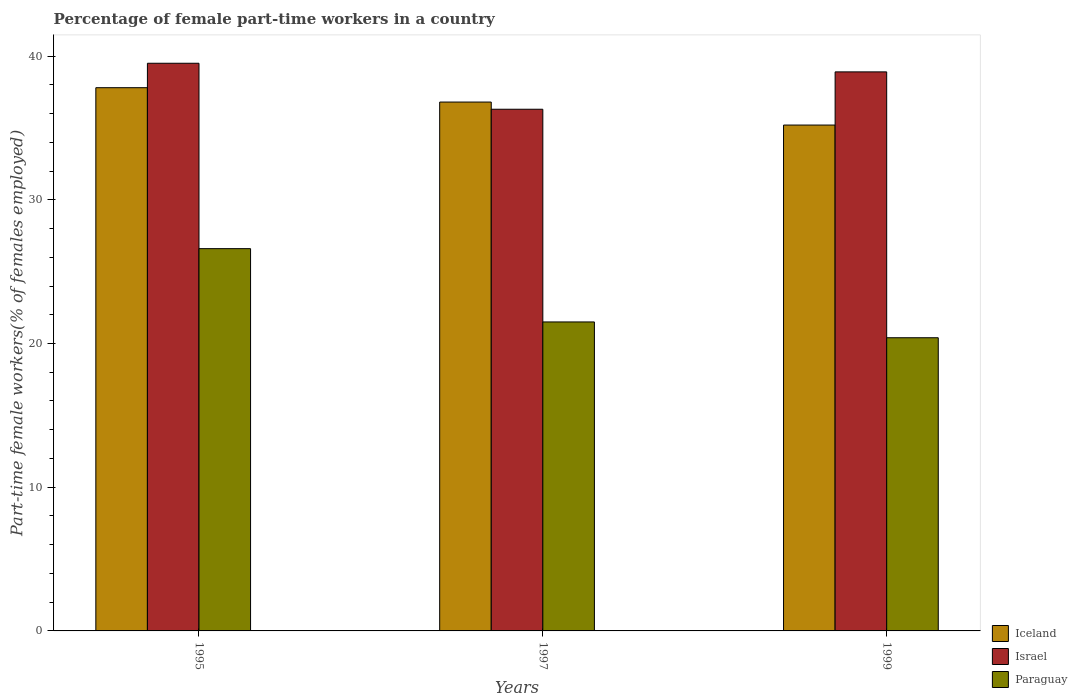How many groups of bars are there?
Offer a terse response. 3. How many bars are there on the 2nd tick from the left?
Make the answer very short. 3. What is the percentage of female part-time workers in Iceland in 1995?
Give a very brief answer. 37.8. Across all years, what is the maximum percentage of female part-time workers in Iceland?
Your response must be concise. 37.8. Across all years, what is the minimum percentage of female part-time workers in Iceland?
Ensure brevity in your answer.  35.2. In which year was the percentage of female part-time workers in Paraguay maximum?
Your answer should be very brief. 1995. What is the total percentage of female part-time workers in Israel in the graph?
Your response must be concise. 114.7. What is the difference between the percentage of female part-time workers in Israel in 1995 and that in 1997?
Provide a succinct answer. 3.2. What is the difference between the percentage of female part-time workers in Israel in 1997 and the percentage of female part-time workers in Iceland in 1995?
Provide a succinct answer. -1.5. What is the average percentage of female part-time workers in Iceland per year?
Your answer should be very brief. 36.6. In the year 1997, what is the difference between the percentage of female part-time workers in Israel and percentage of female part-time workers in Paraguay?
Provide a short and direct response. 14.8. What is the ratio of the percentage of female part-time workers in Israel in 1995 to that in 1999?
Offer a very short reply. 1.02. Is the percentage of female part-time workers in Paraguay in 1995 less than that in 1999?
Your response must be concise. No. Is the difference between the percentage of female part-time workers in Israel in 1995 and 1997 greater than the difference between the percentage of female part-time workers in Paraguay in 1995 and 1997?
Give a very brief answer. No. What is the difference between the highest and the second highest percentage of female part-time workers in Israel?
Ensure brevity in your answer.  0.6. What is the difference between the highest and the lowest percentage of female part-time workers in Israel?
Offer a terse response. 3.2. In how many years, is the percentage of female part-time workers in Iceland greater than the average percentage of female part-time workers in Iceland taken over all years?
Your response must be concise. 2. What does the 2nd bar from the left in 1997 represents?
Offer a terse response. Israel. What does the 1st bar from the right in 1999 represents?
Your response must be concise. Paraguay. How many bars are there?
Ensure brevity in your answer.  9. Are all the bars in the graph horizontal?
Make the answer very short. No. How many years are there in the graph?
Provide a succinct answer. 3. Where does the legend appear in the graph?
Keep it short and to the point. Bottom right. How many legend labels are there?
Offer a very short reply. 3. What is the title of the graph?
Keep it short and to the point. Percentage of female part-time workers in a country. What is the label or title of the X-axis?
Your response must be concise. Years. What is the label or title of the Y-axis?
Provide a succinct answer. Part-time female workers(% of females employed). What is the Part-time female workers(% of females employed) of Iceland in 1995?
Provide a short and direct response. 37.8. What is the Part-time female workers(% of females employed) in Israel in 1995?
Ensure brevity in your answer.  39.5. What is the Part-time female workers(% of females employed) of Paraguay in 1995?
Your response must be concise. 26.6. What is the Part-time female workers(% of females employed) of Iceland in 1997?
Provide a short and direct response. 36.8. What is the Part-time female workers(% of females employed) of Israel in 1997?
Provide a short and direct response. 36.3. What is the Part-time female workers(% of females employed) in Paraguay in 1997?
Offer a very short reply. 21.5. What is the Part-time female workers(% of females employed) in Iceland in 1999?
Offer a very short reply. 35.2. What is the Part-time female workers(% of females employed) in Israel in 1999?
Make the answer very short. 38.9. What is the Part-time female workers(% of females employed) in Paraguay in 1999?
Give a very brief answer. 20.4. Across all years, what is the maximum Part-time female workers(% of females employed) of Iceland?
Your answer should be very brief. 37.8. Across all years, what is the maximum Part-time female workers(% of females employed) in Israel?
Offer a very short reply. 39.5. Across all years, what is the maximum Part-time female workers(% of females employed) of Paraguay?
Offer a terse response. 26.6. Across all years, what is the minimum Part-time female workers(% of females employed) in Iceland?
Make the answer very short. 35.2. Across all years, what is the minimum Part-time female workers(% of females employed) of Israel?
Your answer should be compact. 36.3. Across all years, what is the minimum Part-time female workers(% of females employed) in Paraguay?
Offer a very short reply. 20.4. What is the total Part-time female workers(% of females employed) in Iceland in the graph?
Your answer should be compact. 109.8. What is the total Part-time female workers(% of females employed) in Israel in the graph?
Your answer should be compact. 114.7. What is the total Part-time female workers(% of females employed) of Paraguay in the graph?
Provide a succinct answer. 68.5. What is the difference between the Part-time female workers(% of females employed) of Paraguay in 1995 and that in 1997?
Keep it short and to the point. 5.1. What is the difference between the Part-time female workers(% of females employed) in Iceland in 1995 and that in 1999?
Make the answer very short. 2.6. What is the difference between the Part-time female workers(% of females employed) in Paraguay in 1995 and that in 1999?
Your answer should be compact. 6.2. What is the difference between the Part-time female workers(% of females employed) in Iceland in 1997 and that in 1999?
Provide a succinct answer. 1.6. What is the difference between the Part-time female workers(% of females employed) of Israel in 1997 and that in 1999?
Offer a terse response. -2.6. What is the difference between the Part-time female workers(% of females employed) in Iceland in 1995 and the Part-time female workers(% of females employed) in Israel in 1997?
Ensure brevity in your answer.  1.5. What is the difference between the Part-time female workers(% of females employed) of Israel in 1995 and the Part-time female workers(% of females employed) of Paraguay in 1997?
Offer a terse response. 18. What is the difference between the Part-time female workers(% of females employed) of Israel in 1995 and the Part-time female workers(% of females employed) of Paraguay in 1999?
Provide a short and direct response. 19.1. What is the difference between the Part-time female workers(% of females employed) in Iceland in 1997 and the Part-time female workers(% of females employed) in Israel in 1999?
Offer a terse response. -2.1. What is the difference between the Part-time female workers(% of females employed) in Iceland in 1997 and the Part-time female workers(% of females employed) in Paraguay in 1999?
Keep it short and to the point. 16.4. What is the average Part-time female workers(% of females employed) in Iceland per year?
Keep it short and to the point. 36.6. What is the average Part-time female workers(% of females employed) of Israel per year?
Make the answer very short. 38.23. What is the average Part-time female workers(% of females employed) in Paraguay per year?
Your response must be concise. 22.83. In the year 1995, what is the difference between the Part-time female workers(% of females employed) in Israel and Part-time female workers(% of females employed) in Paraguay?
Your response must be concise. 12.9. In the year 1997, what is the difference between the Part-time female workers(% of females employed) of Iceland and Part-time female workers(% of females employed) of Israel?
Your response must be concise. 0.5. In the year 1999, what is the difference between the Part-time female workers(% of females employed) in Israel and Part-time female workers(% of females employed) in Paraguay?
Offer a terse response. 18.5. What is the ratio of the Part-time female workers(% of females employed) of Iceland in 1995 to that in 1997?
Offer a terse response. 1.03. What is the ratio of the Part-time female workers(% of females employed) in Israel in 1995 to that in 1997?
Your answer should be compact. 1.09. What is the ratio of the Part-time female workers(% of females employed) in Paraguay in 1995 to that in 1997?
Offer a very short reply. 1.24. What is the ratio of the Part-time female workers(% of females employed) in Iceland in 1995 to that in 1999?
Provide a succinct answer. 1.07. What is the ratio of the Part-time female workers(% of females employed) in Israel in 1995 to that in 1999?
Ensure brevity in your answer.  1.02. What is the ratio of the Part-time female workers(% of females employed) in Paraguay in 1995 to that in 1999?
Ensure brevity in your answer.  1.3. What is the ratio of the Part-time female workers(% of females employed) of Iceland in 1997 to that in 1999?
Ensure brevity in your answer.  1.05. What is the ratio of the Part-time female workers(% of females employed) of Israel in 1997 to that in 1999?
Your answer should be very brief. 0.93. What is the ratio of the Part-time female workers(% of females employed) of Paraguay in 1997 to that in 1999?
Your response must be concise. 1.05. What is the difference between the highest and the second highest Part-time female workers(% of females employed) in Israel?
Provide a short and direct response. 0.6. What is the difference between the highest and the second highest Part-time female workers(% of females employed) of Paraguay?
Ensure brevity in your answer.  5.1. What is the difference between the highest and the lowest Part-time female workers(% of females employed) in Iceland?
Offer a very short reply. 2.6. What is the difference between the highest and the lowest Part-time female workers(% of females employed) of Israel?
Your answer should be compact. 3.2. 